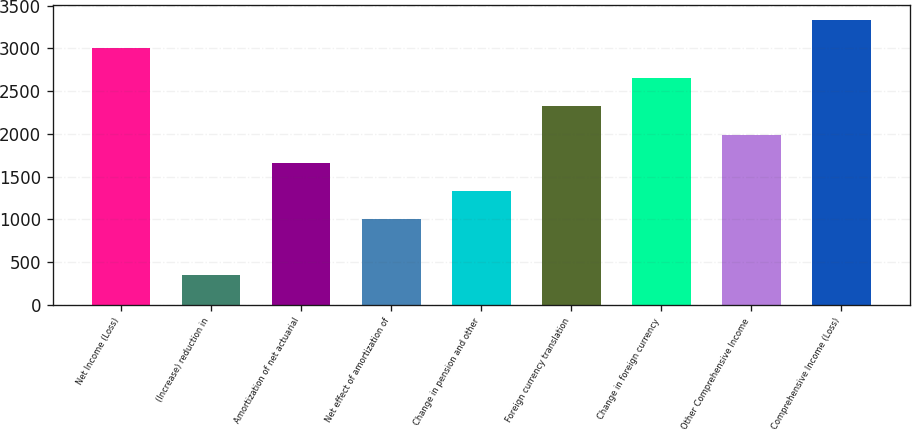<chart> <loc_0><loc_0><loc_500><loc_500><bar_chart><fcel>Net Income (Loss)<fcel>(Increase) reduction in<fcel>Amortization of net actuarial<fcel>Net effect of amortization of<fcel>Change in pension and other<fcel>Foreign currency translation<fcel>Change in foreign currency<fcel>Other Comprehensive Income<fcel>Comprehensive Income (Loss)<nl><fcel>3007<fcel>346.3<fcel>1663.5<fcel>1004.9<fcel>1334.2<fcel>2322.1<fcel>2651.4<fcel>1992.8<fcel>3336.3<nl></chart> 